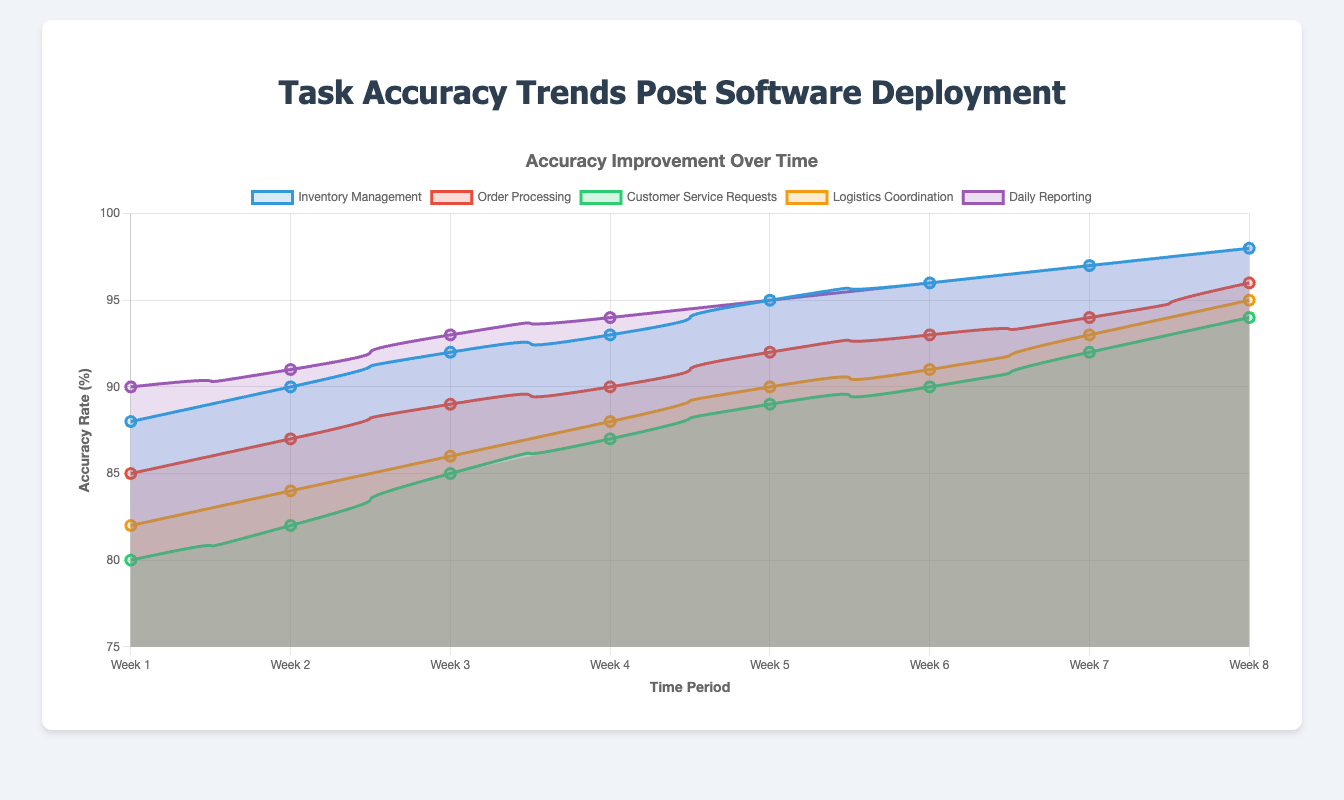Which task showed the highest accuracy rate in Week 8? In Week 8, the accuracy rates for each task are: Inventory Management (98), Order Processing (96), Customer Service Requests (94), Logistics Coordination (95), and Daily Reporting (98). The highest rates are for Inventory Management and Daily Reporting.
Answer: Inventory Management and Daily Reporting Which task experienced the greatest reduction in error rate from Week 1 to Week 8? To find the greatest reduction in error rate, we look at the difference between Week 1 and Week 8 for each task. Inventory Management: 12-2=10, Order Processing: 15-4=11, Customer Service Requests: 20-6=14, Logistics Coordination: 18-5=13, Daily Reporting: 10-2=8. The greatest reduction is for Customer Service Requests.
Answer: Customer Service Requests What is the average accuracy rate for Logistics Coordination from Week 1 to Week 8? Sum the weekly accuracy rates for Logistics Coordination: 82 + 84 + 86 + 88 + 90 + 91 + 93 + 95 = 709. Divide this by the number of weeks (8): 709 / 8 = 88.625.
Answer: 88.625 Compare the accuracy improvement between Week 4 and Week 8 for Inventory Management and Order Processing. Which task had a greater improvement? Inventory Management improved from 93 to 98, an increase of 5. Order Processing improved from 90 to 96, an increase of 6. Order Processing had a greater improvement.
Answer: Order Processing In Week 6, which task had the lowest accuracy rate? The accuracy rates in Week 6 are: Inventory Management (96), Order Processing (93), Customer Service Requests (90), Logistics Coordination (91), Daily Reporting (96). The lowest accuracy rate is for Customer Service Requests.
Answer: Customer Service Requests 